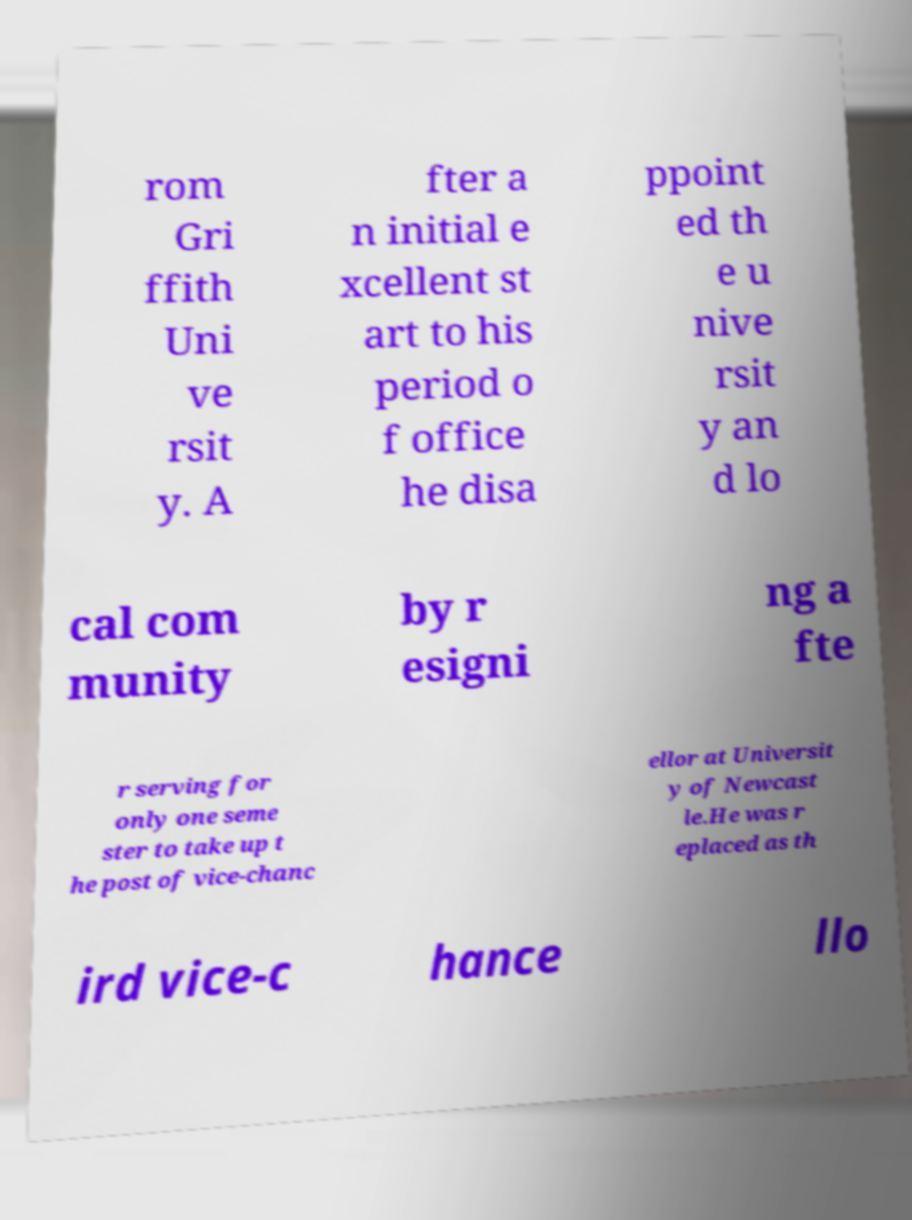There's text embedded in this image that I need extracted. Can you transcribe it verbatim? rom Gri ffith Uni ve rsit y. A fter a n initial e xcellent st art to his period o f office he disa ppoint ed th e u nive rsit y an d lo cal com munity by r esigni ng a fte r serving for only one seme ster to take up t he post of vice-chanc ellor at Universit y of Newcast le.He was r eplaced as th ird vice-c hance llo 